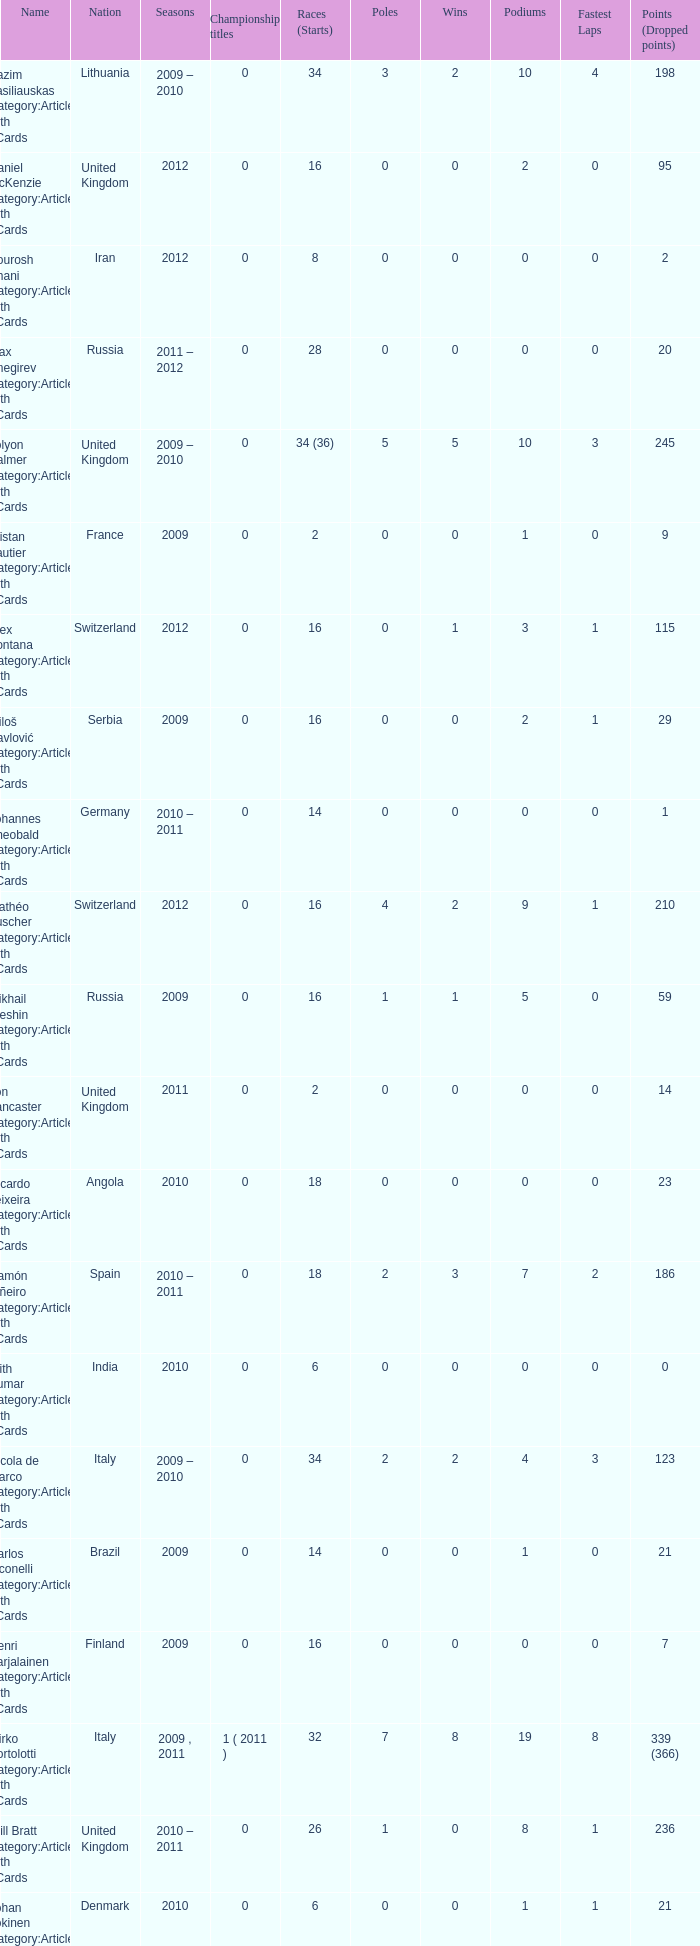What was the least amount of wins? 0.0. 